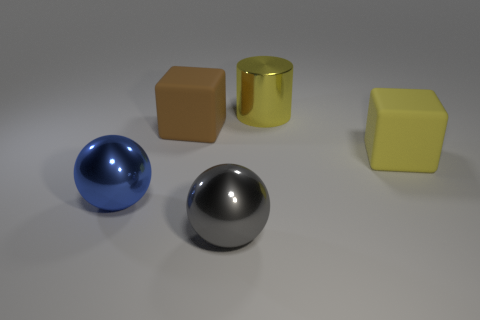What size is the block that is the same color as the big cylinder?
Keep it short and to the point. Large. What number of things are large blue metallic things or blocks?
Offer a terse response. 3. What color is the cylinder that is the same size as the gray ball?
Keep it short and to the point. Yellow. Do the brown thing and the rubber thing that is to the right of the gray metallic sphere have the same shape?
Offer a very short reply. Yes. How many objects are either matte things that are on the left side of the gray object or shiny things that are right of the big blue metallic ball?
Keep it short and to the point. 3. The rubber object that is the same color as the big cylinder is what shape?
Keep it short and to the point. Cube. There is a metallic object behind the big blue object; what is its shape?
Provide a short and direct response. Cylinder. There is a big thing in front of the large blue sphere; is its shape the same as the big brown matte object?
Offer a terse response. No. How many objects are rubber blocks that are on the left side of the large yellow cylinder or small blue cylinders?
Your answer should be compact. 1. There is another big rubber thing that is the same shape as the brown matte object; what color is it?
Provide a succinct answer. Yellow. 